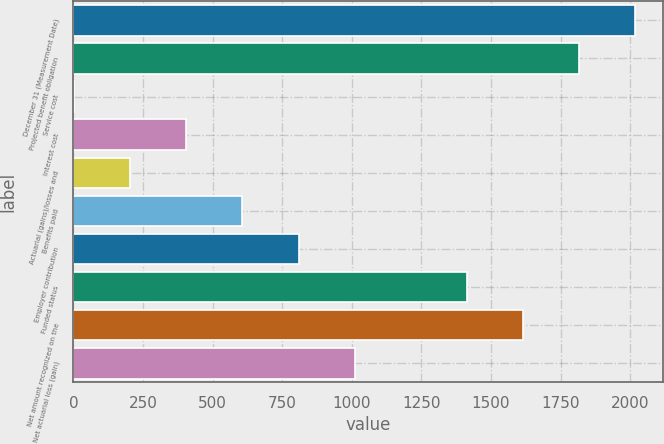<chart> <loc_0><loc_0><loc_500><loc_500><bar_chart><fcel>December 31 (Measurement Date)<fcel>Projected benefit obligation<fcel>Service cost<fcel>Interest cost<fcel>Actuarial (gains)/losses and<fcel>Benefits paid<fcel>Employer contribution<fcel>Funded status<fcel>Net amount recognized on the<fcel>Net actuarial loss (gain)<nl><fcel>2017<fcel>1815.6<fcel>3<fcel>405.8<fcel>204.4<fcel>607.2<fcel>808.6<fcel>1412.8<fcel>1614.2<fcel>1010<nl></chart> 